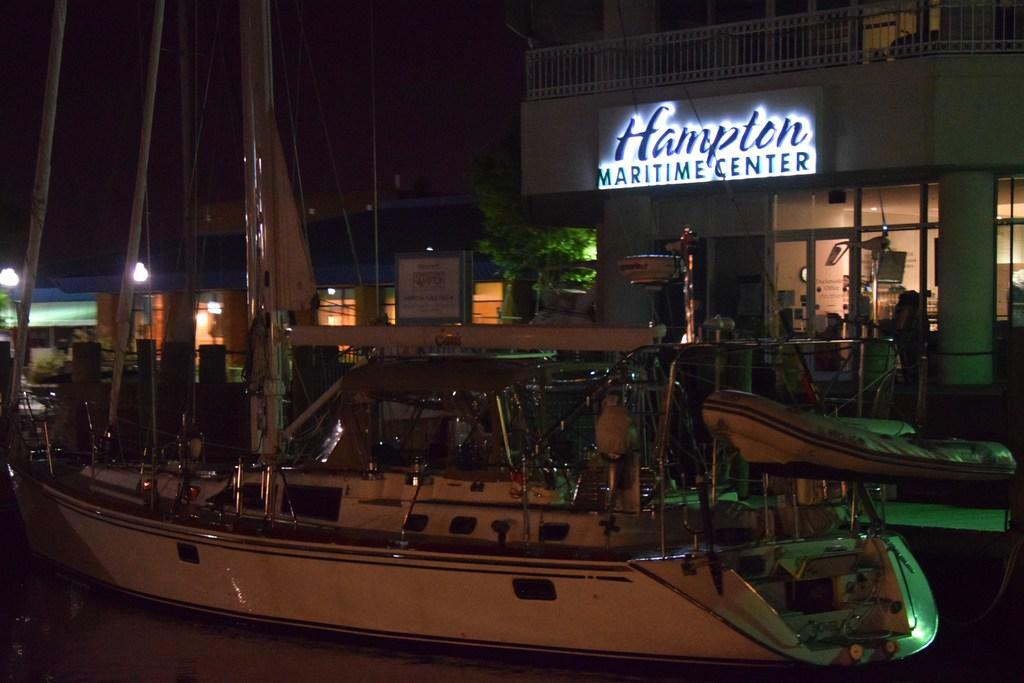What type of vehicles can be seen in the image? There are boats in the image. What type of structures are present in the image? There are buildings in the image. What can be seen illuminating the scene in the image? There are lights visible in the image. What type of vegetation is present in the image? There are trees in the image. What type of leather material can be seen covering the boats in the image? There is no leather material present on the boats in the image. How many planes can be seen flying in the image? There are no planes visible in the image. 